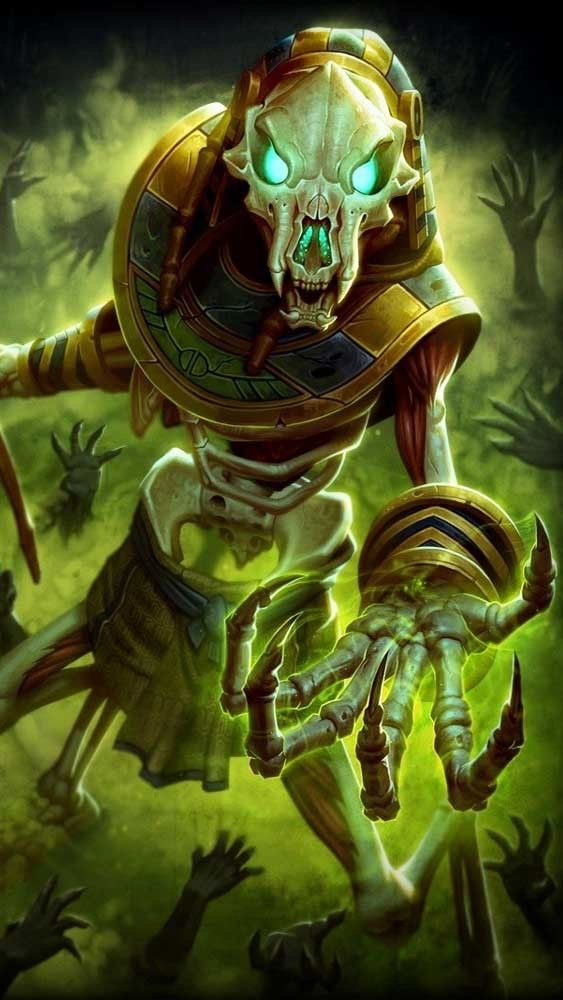describe this image in great detail, including details like the art style, medium, colors, and objects in the image. the word limit is 99  This digital artwork depicts a skeletal warrior in ornate golden armor. The figure has a menacing skull face with glowing blue eyes, creating an eerie, otherworldly effect. The armor is intricately detailed with ancient Egyptian-inspired designs. The warrior's pose is dynamic, lunging forward with a clawed hand outstretched.

The color palette is dominated by shades of gold and sickly green, creating a mystical, undead atmosphere. Dark shadows and a misty background add depth and mystery. Ghostly hands reach up from the bottom, suggesting a horde of undead minions.

The art style is highly detailed and fantastical, blending elements of horror and high fantasy. The overall effect is of a powerful, nightmarish entity emerging from the depths of the underworld. 